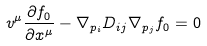<formula> <loc_0><loc_0><loc_500><loc_500>v ^ { \mu } \frac { \partial f _ { 0 } } { \partial x ^ { \mu } } - \nabla _ { p _ { i } } { D _ { i j } } \nabla _ { p _ { j } } f _ { 0 } = 0</formula> 